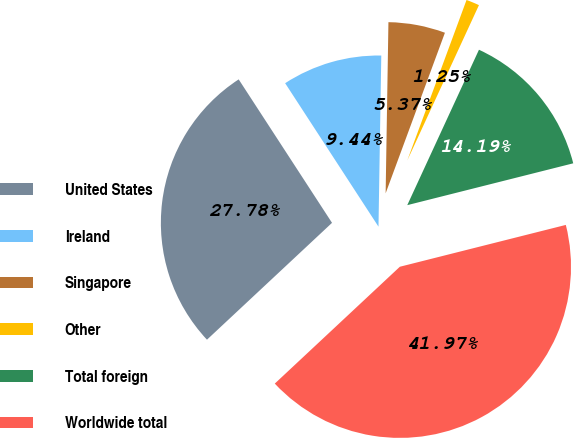Convert chart to OTSL. <chart><loc_0><loc_0><loc_500><loc_500><pie_chart><fcel>United States<fcel>Ireland<fcel>Singapore<fcel>Other<fcel>Total foreign<fcel>Worldwide total<nl><fcel>27.78%<fcel>9.44%<fcel>5.37%<fcel>1.25%<fcel>14.19%<fcel>41.97%<nl></chart> 